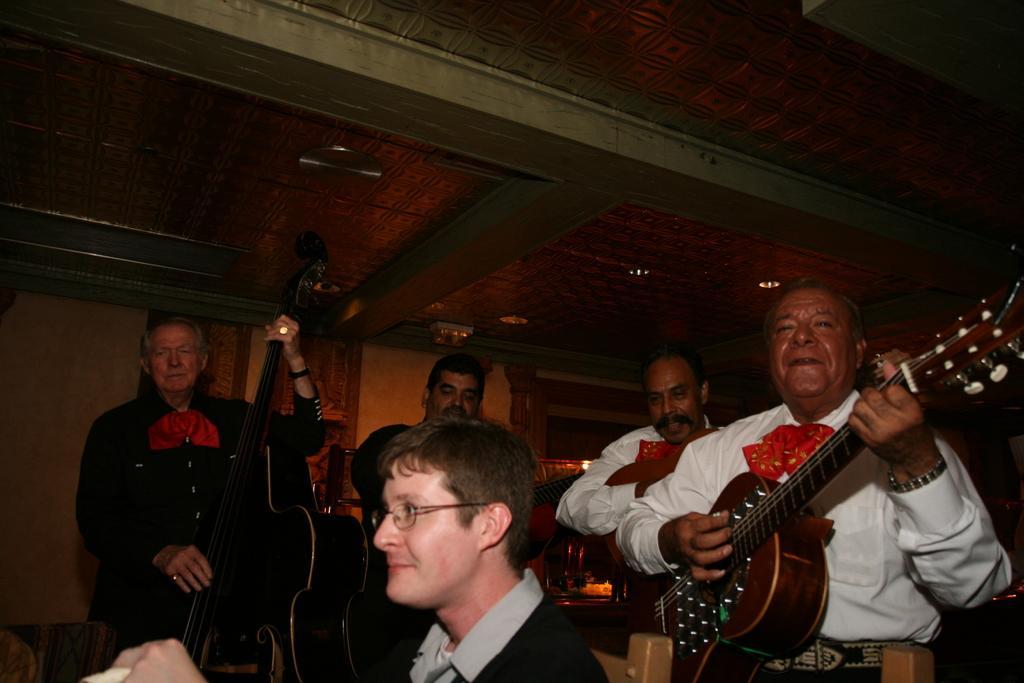Please provide a concise description of this image. In this picture we can see a group of people playing musical instruments such as guitar, violin and here person wore spectacle and smiling and in background we can see wall. lights. 